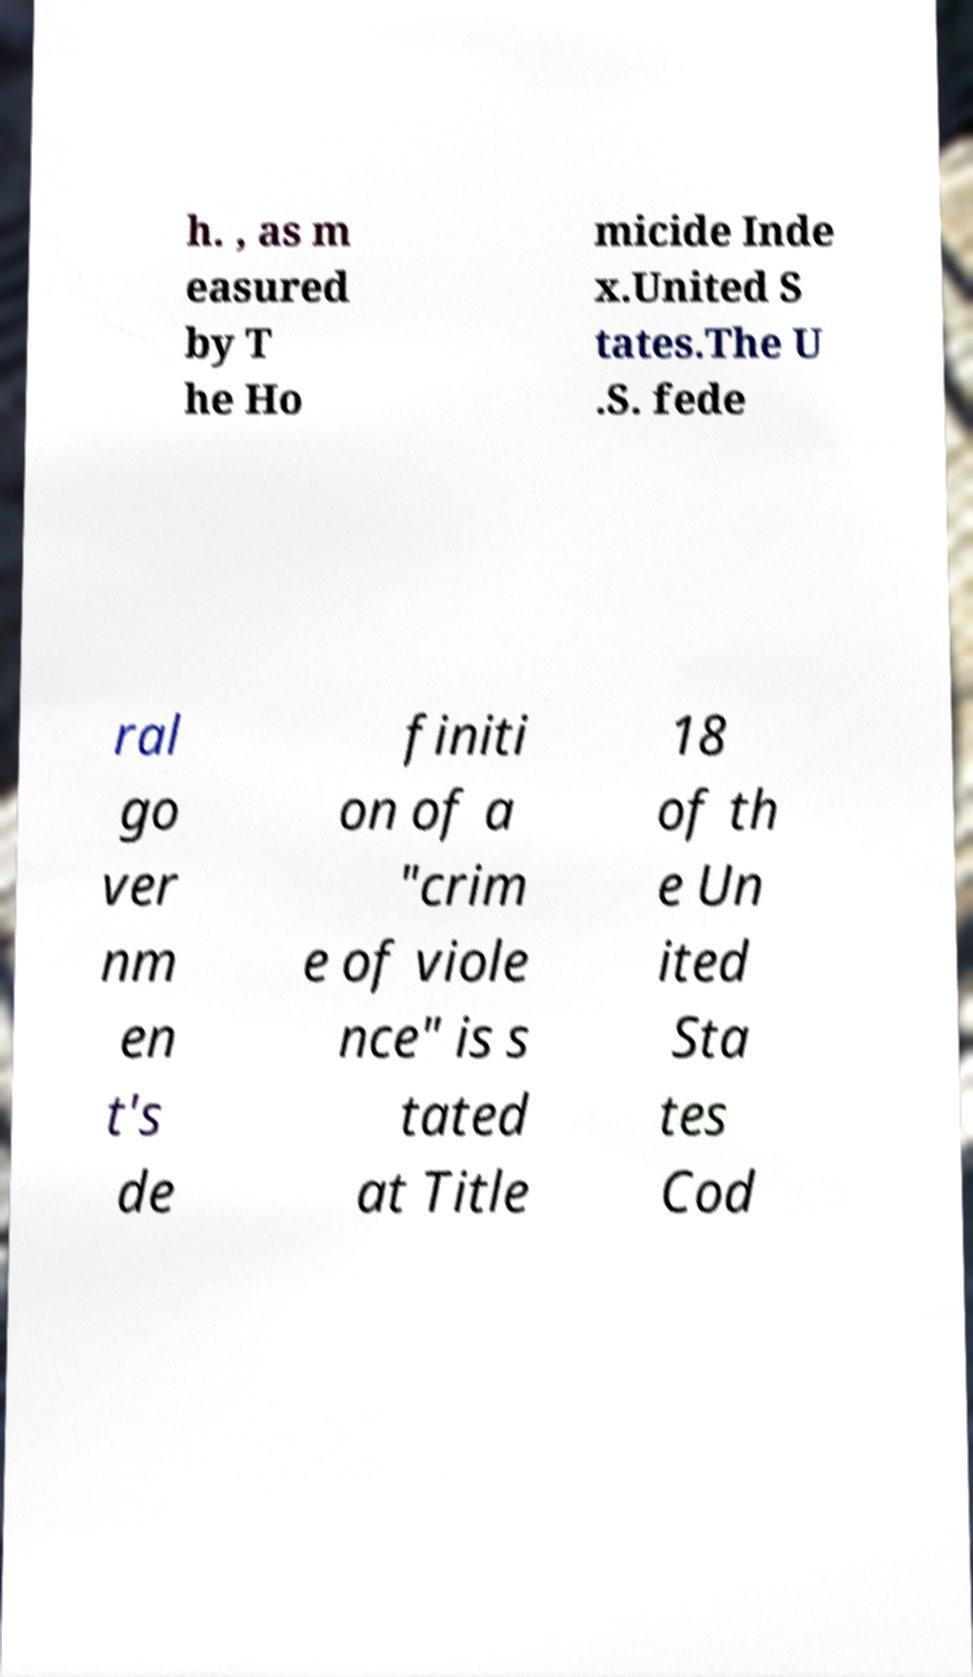Please identify and transcribe the text found in this image. h. , as m easured by T he Ho micide Inde x.United S tates.The U .S. fede ral go ver nm en t's de finiti on of a "crim e of viole nce" is s tated at Title 18 of th e Un ited Sta tes Cod 